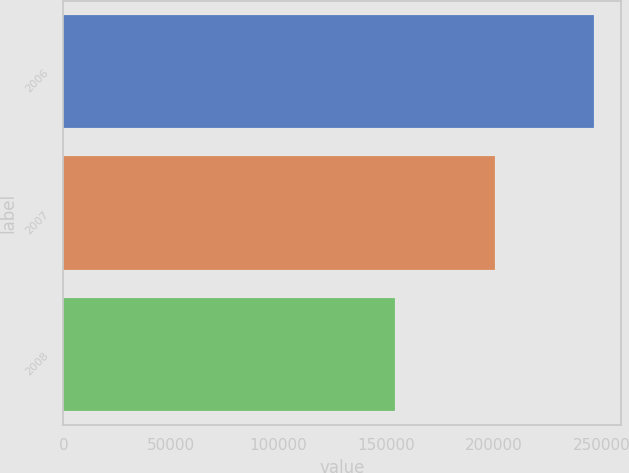Convert chart. <chart><loc_0><loc_0><loc_500><loc_500><bar_chart><fcel>2006<fcel>2007<fcel>2008<nl><fcel>246588<fcel>200589<fcel>153996<nl></chart> 